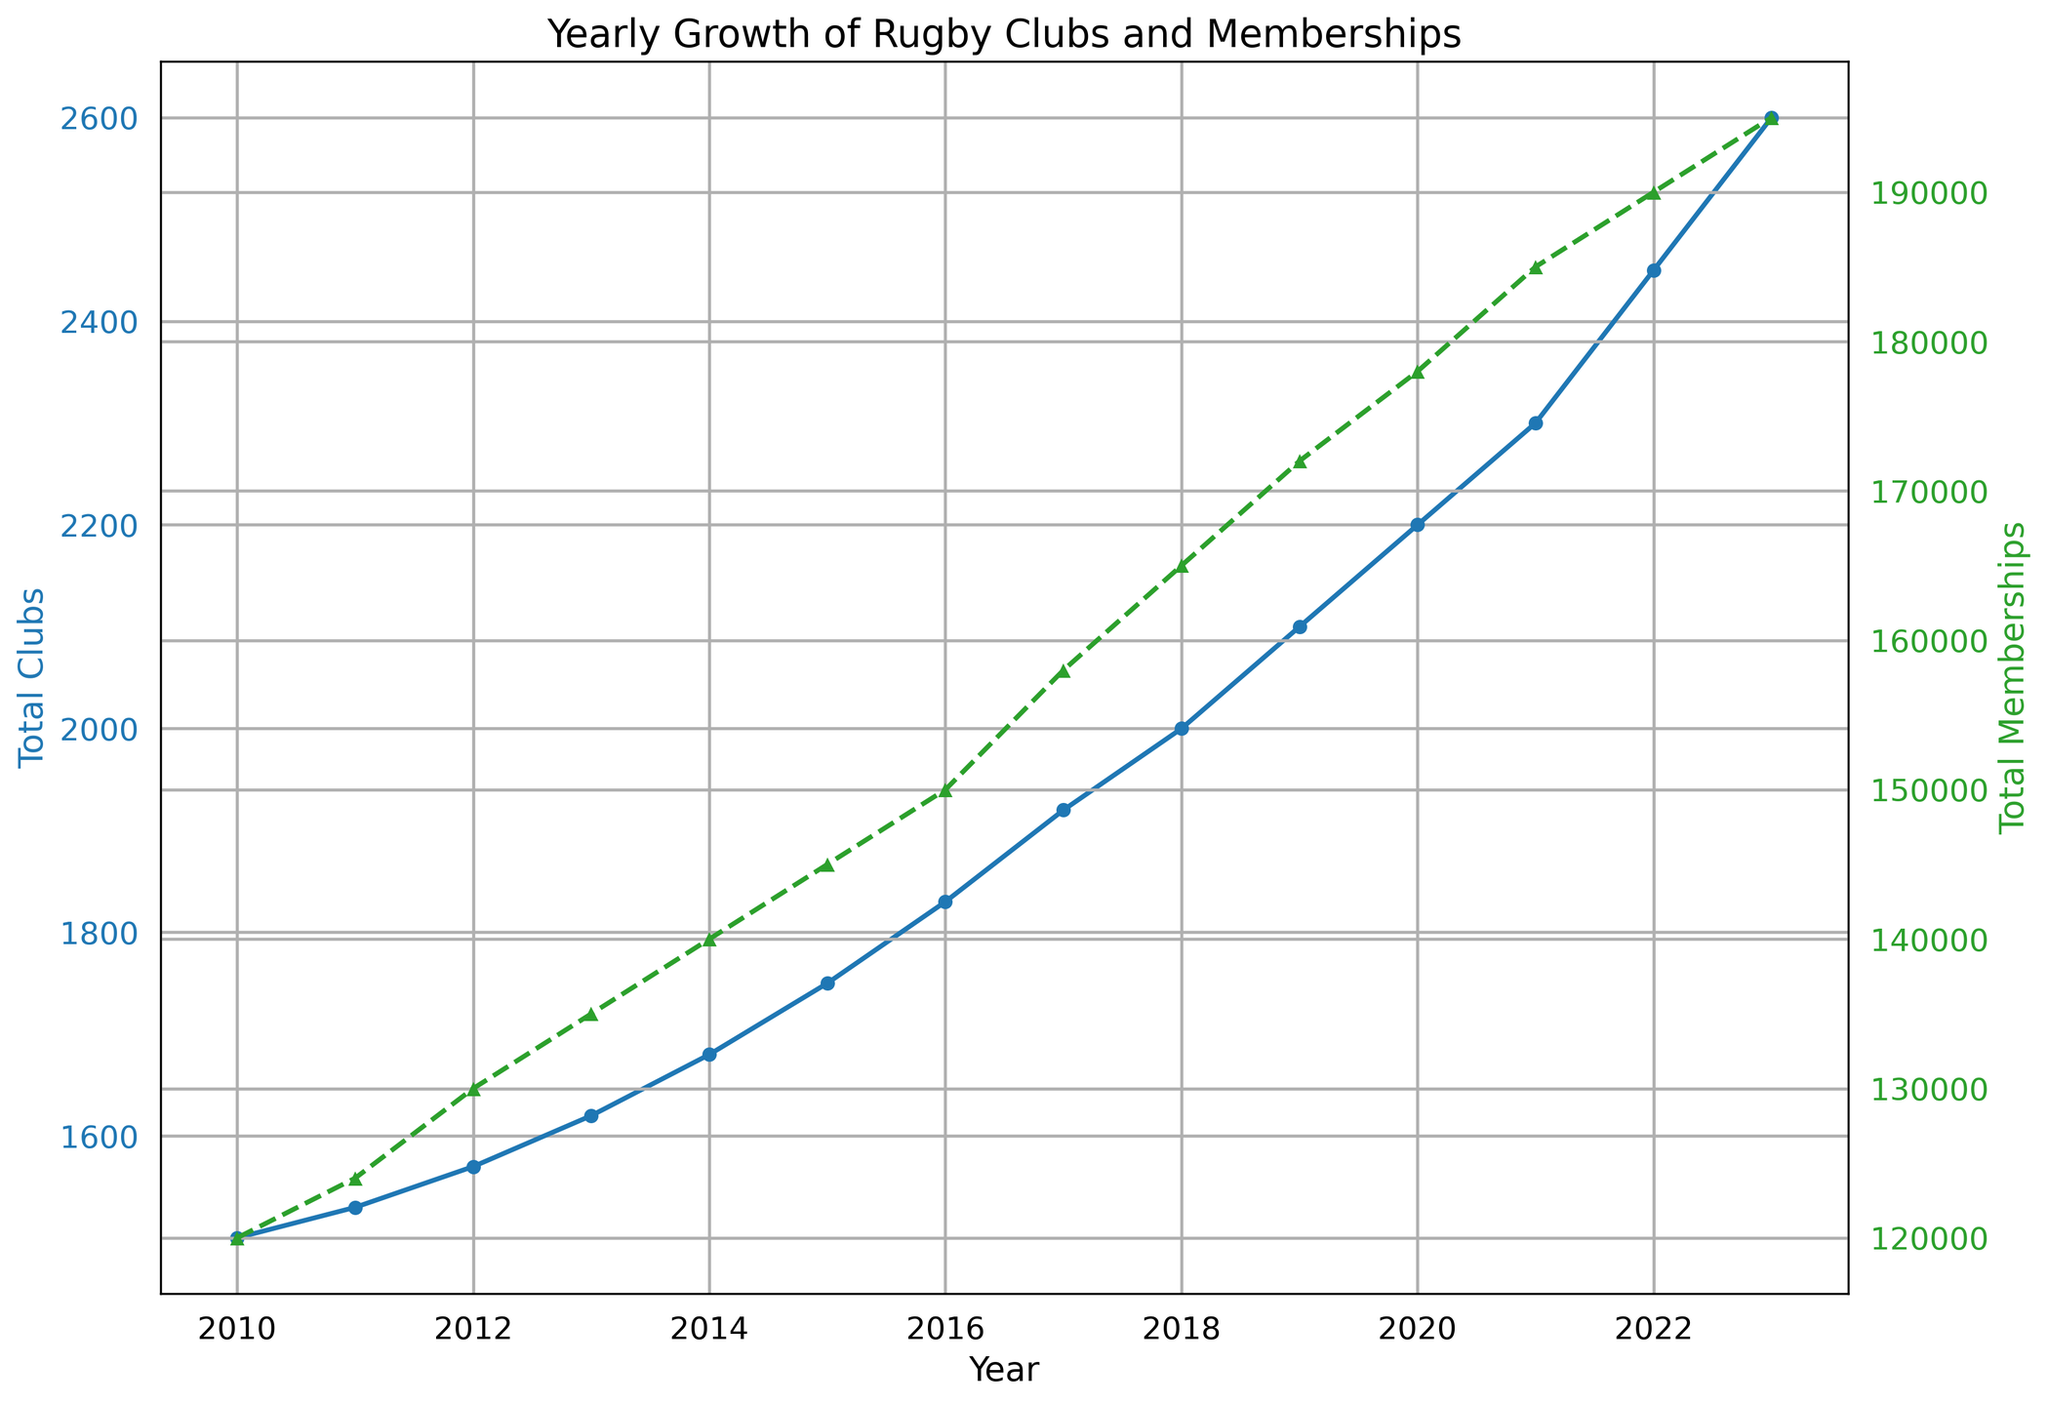How many rugby clubs were there in the UK in 2013? Looking at the blue line on the chart for the year 2013, we find the total number of clubs is marked. The precise value indicated is 1620.
Answer: 1620 Which year had the highest number of rugby club memberships? By focusing on the green line and finding the year at the peak of the chart, we identify that the highest number of memberships occurred in 2023 with 195000 memberships.
Answer: 2023 How much did the total number of rugby clubs increase from 2010 to 2023? Starting from 1500 clubs in 2010 and increasing to 2600 clubs in 2023, the difference is computed as 2600 - 1500, which equals 1100.
Answer: 1100 Did the number of total memberships ever decrease between 2010 and 2023? Observing the green line on the chart, we can see that the number of total memberships steadily increases each year without any decrease.
Answer: No What is the average growth in total rugby clubs per year between 2010 and 2023? The total growth in rugby clubs from 2010 to 2023 is 2600 - 1500 = 1100. Since there are 13 years from 2010 to 2023, we divide 1100 by 13 to get an average growth of approximately 84.62 clubs per year.
Answer: 84.62 Which year saw a greater increase in rugby clubs, 2011 or 2012? From 2010 to 2011, clubs increased from 1500 to 1530 (30 clubs). From 2011 to 2012, clubs increased from 1530 to 1570 (40 clubs). Therefore, 2012 saw a greater increase.
Answer: 2012 What is the difference in the number of memberships between the years 2015 and 2020? In 2015, there were 145000 memberships. In 2020, there were 178000 memberships. The difference is 178000 - 145000, which equals 33000.
Answer: 33000 By how much did the number of memberships increase from 2017 to 2018? The number of total memberships in 2017 was 158000, and it increased to 165000 in 2018. The increase is calculated as 165000 - 158000, resulting in 7000.
Answer: 7000 Which year had more rugby clubs: 2014 or 2016? Comparing the blue line for the years 2014 and 2016, we see that in 2014 there were 1680 clubs while in 2016 there were 1830 clubs. Therefore, 2016 had more clubs.
Answer: 2016 What trend can be seen in both clubs and memberships from 2010 to 2023? Observing the overall direction of both lines, there's a consistent upward trend for both the total number of rugby clubs and memberships from 2010 to 2023.
Answer: Upward trend 